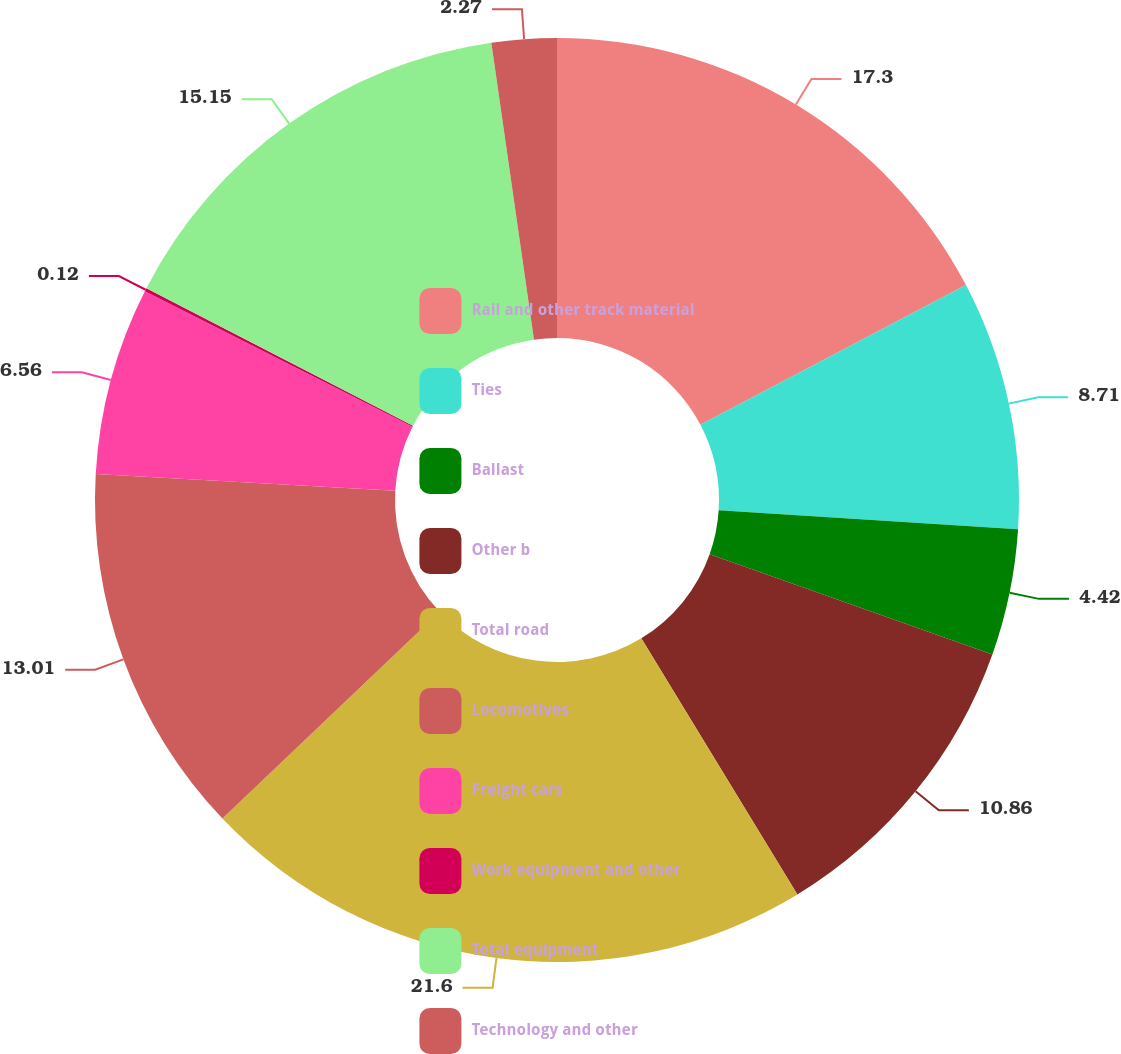Convert chart. <chart><loc_0><loc_0><loc_500><loc_500><pie_chart><fcel>Rail and other track material<fcel>Ties<fcel>Ballast<fcel>Other b<fcel>Total road<fcel>Locomotives<fcel>Freight cars<fcel>Work equipment and other<fcel>Total equipment<fcel>Technology and other<nl><fcel>17.3%<fcel>8.71%<fcel>4.42%<fcel>10.86%<fcel>21.6%<fcel>13.01%<fcel>6.56%<fcel>0.12%<fcel>15.15%<fcel>2.27%<nl></chart> 